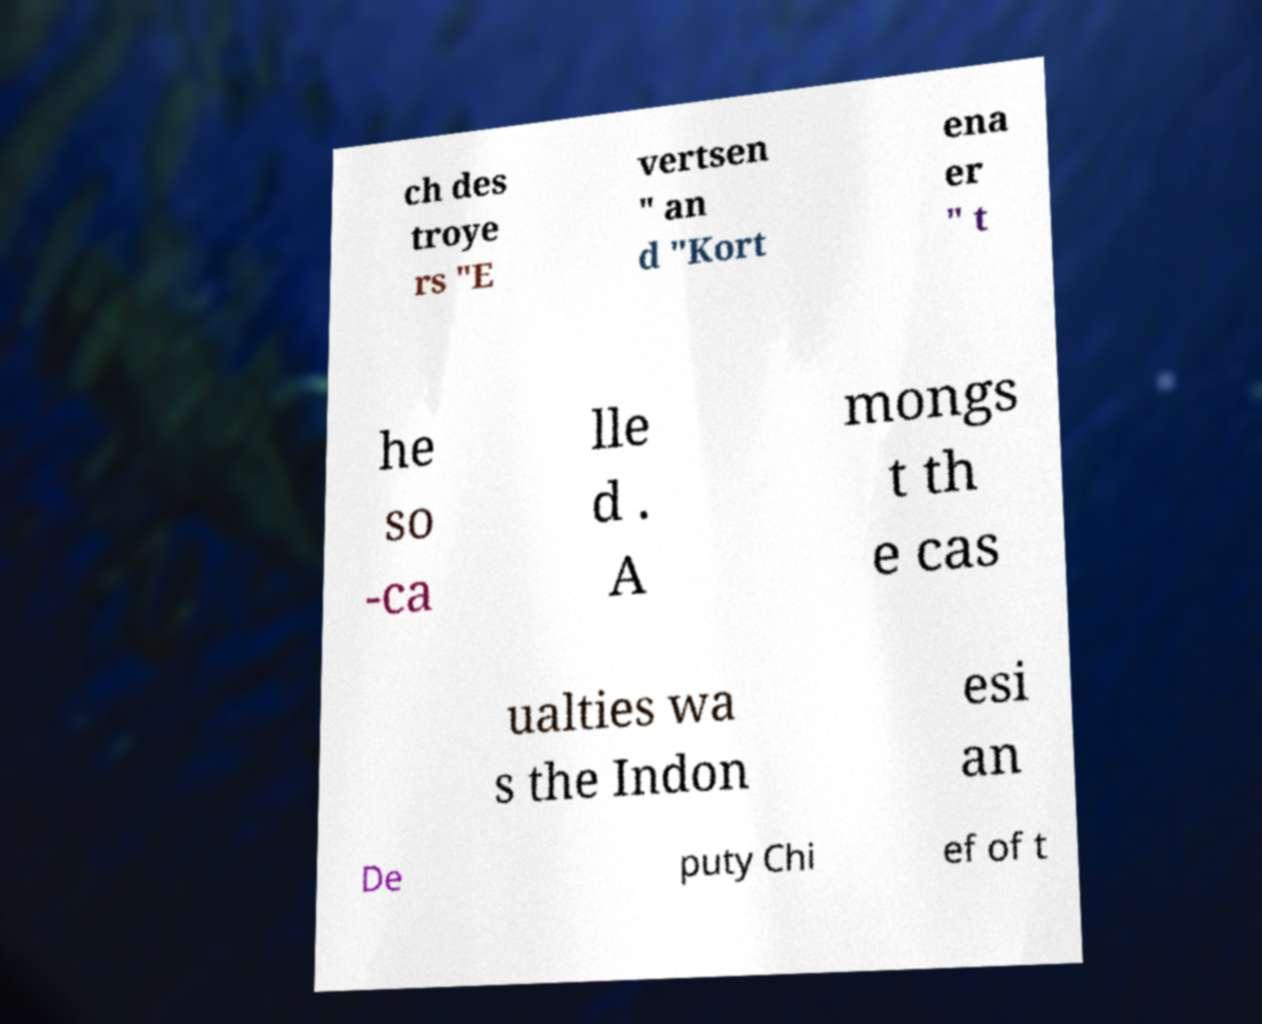There's text embedded in this image that I need extracted. Can you transcribe it verbatim? ch des troye rs "E vertsen " an d "Kort ena er " t he so -ca lle d . A mongs t th e cas ualties wa s the Indon esi an De puty Chi ef of t 